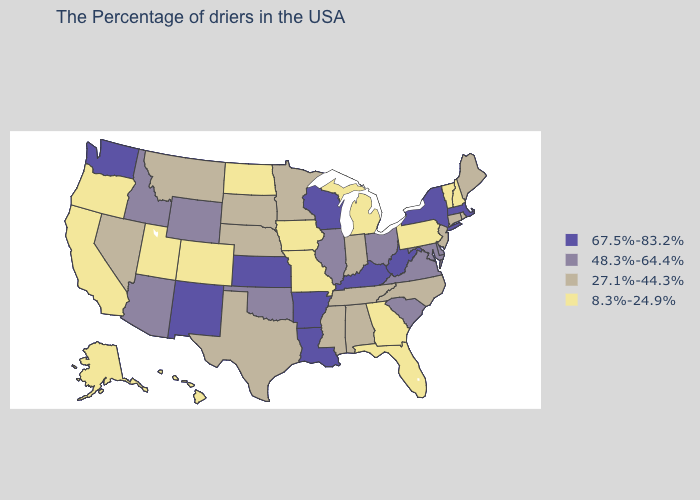Name the states that have a value in the range 48.3%-64.4%?
Short answer required. Delaware, Maryland, Virginia, South Carolina, Ohio, Illinois, Oklahoma, Wyoming, Arizona, Idaho. Which states have the lowest value in the USA?
Be succinct. New Hampshire, Vermont, Pennsylvania, Florida, Georgia, Michigan, Missouri, Iowa, North Dakota, Colorado, Utah, California, Oregon, Alaska, Hawaii. What is the value of Kansas?
Answer briefly. 67.5%-83.2%. Among the states that border South Carolina , which have the lowest value?
Short answer required. Georgia. Does Indiana have a lower value than Oregon?
Quick response, please. No. Does Louisiana have the highest value in the USA?
Write a very short answer. Yes. Does Alaska have the lowest value in the USA?
Quick response, please. Yes. What is the value of Illinois?
Be succinct. 48.3%-64.4%. Does the map have missing data?
Be succinct. No. What is the value of Maine?
Keep it brief. 27.1%-44.3%. Name the states that have a value in the range 27.1%-44.3%?
Quick response, please. Maine, Rhode Island, Connecticut, New Jersey, North Carolina, Indiana, Alabama, Tennessee, Mississippi, Minnesota, Nebraska, Texas, South Dakota, Montana, Nevada. Among the states that border Utah , does Arizona have the highest value?
Answer briefly. No. Is the legend a continuous bar?
Concise answer only. No. What is the value of Tennessee?
Concise answer only. 27.1%-44.3%. Name the states that have a value in the range 8.3%-24.9%?
Write a very short answer. New Hampshire, Vermont, Pennsylvania, Florida, Georgia, Michigan, Missouri, Iowa, North Dakota, Colorado, Utah, California, Oregon, Alaska, Hawaii. 